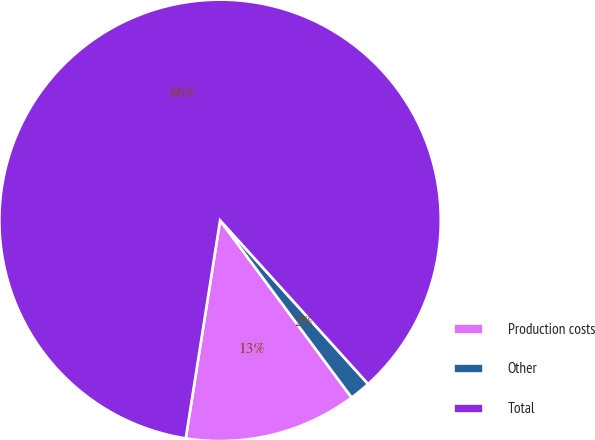Convert chart to OTSL. <chart><loc_0><loc_0><loc_500><loc_500><pie_chart><fcel>Production costs<fcel>Other<fcel>Total<nl><fcel>12.65%<fcel>1.54%<fcel>85.81%<nl></chart> 